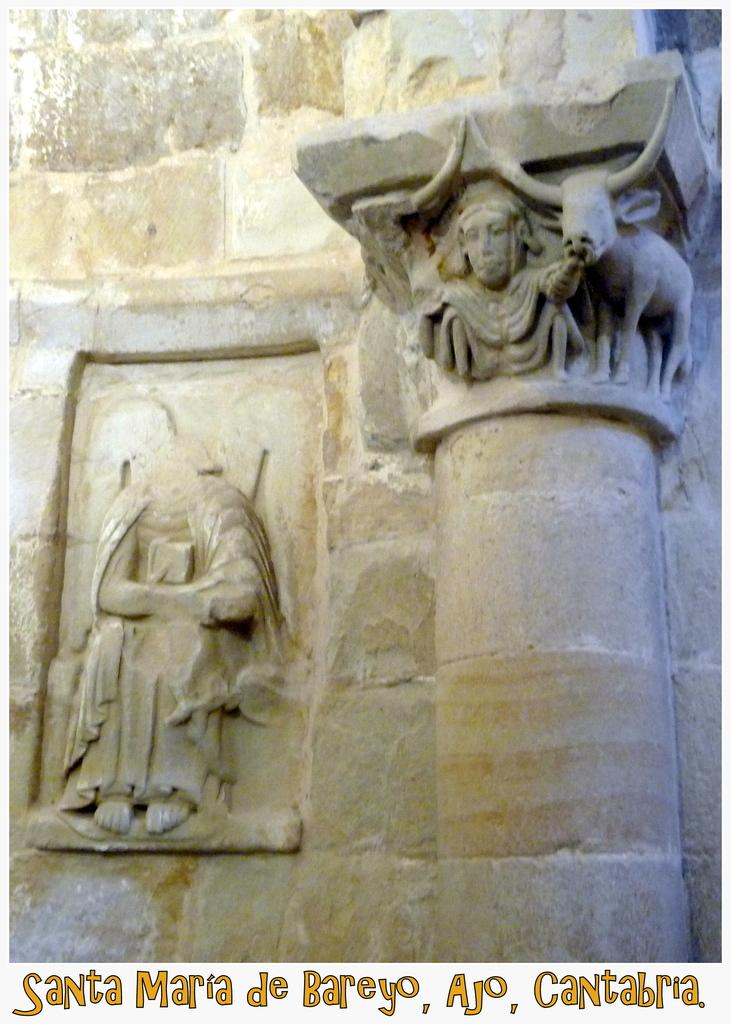What is the main subject of the image? The main subject of the image is a carved stone. Is there any additional information or markings in the image? Yes, there is a watermark at the bottom of the image. What type of canvas is used to create the lamp in the image? There is no lamp present in the image; it only features a carved stone and a watermark. 